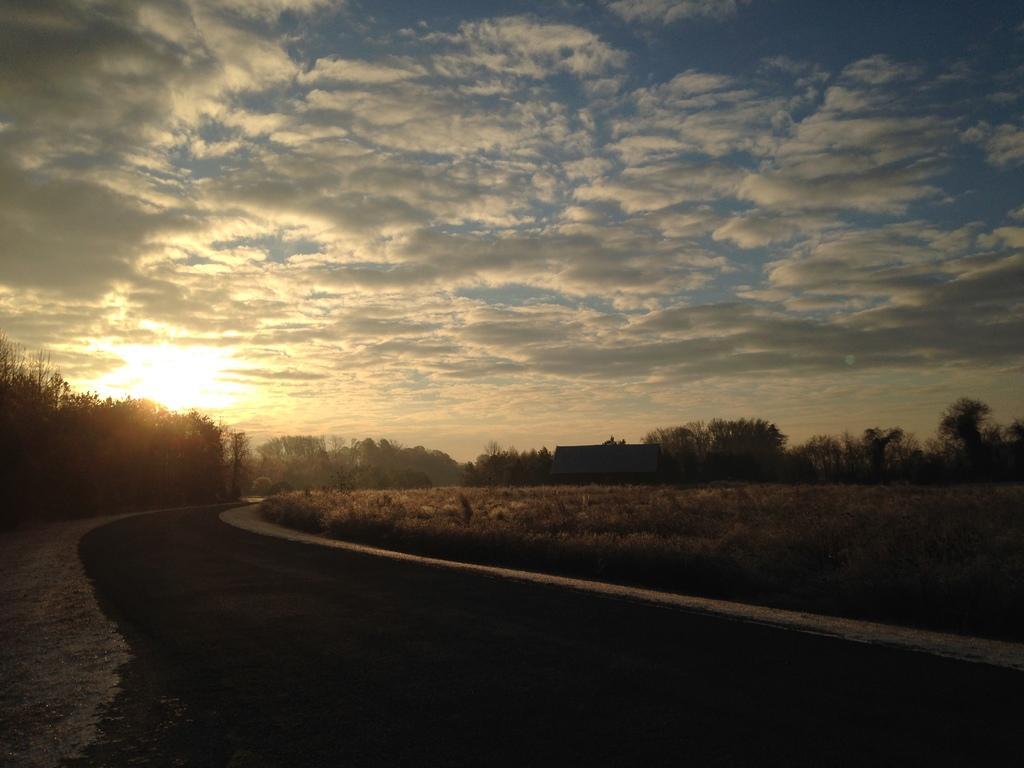Describe this image in one or two sentences. In this image at the bottom there is a road and some plants and in the background there are some trees, and one house on the top of the image there is sky. 